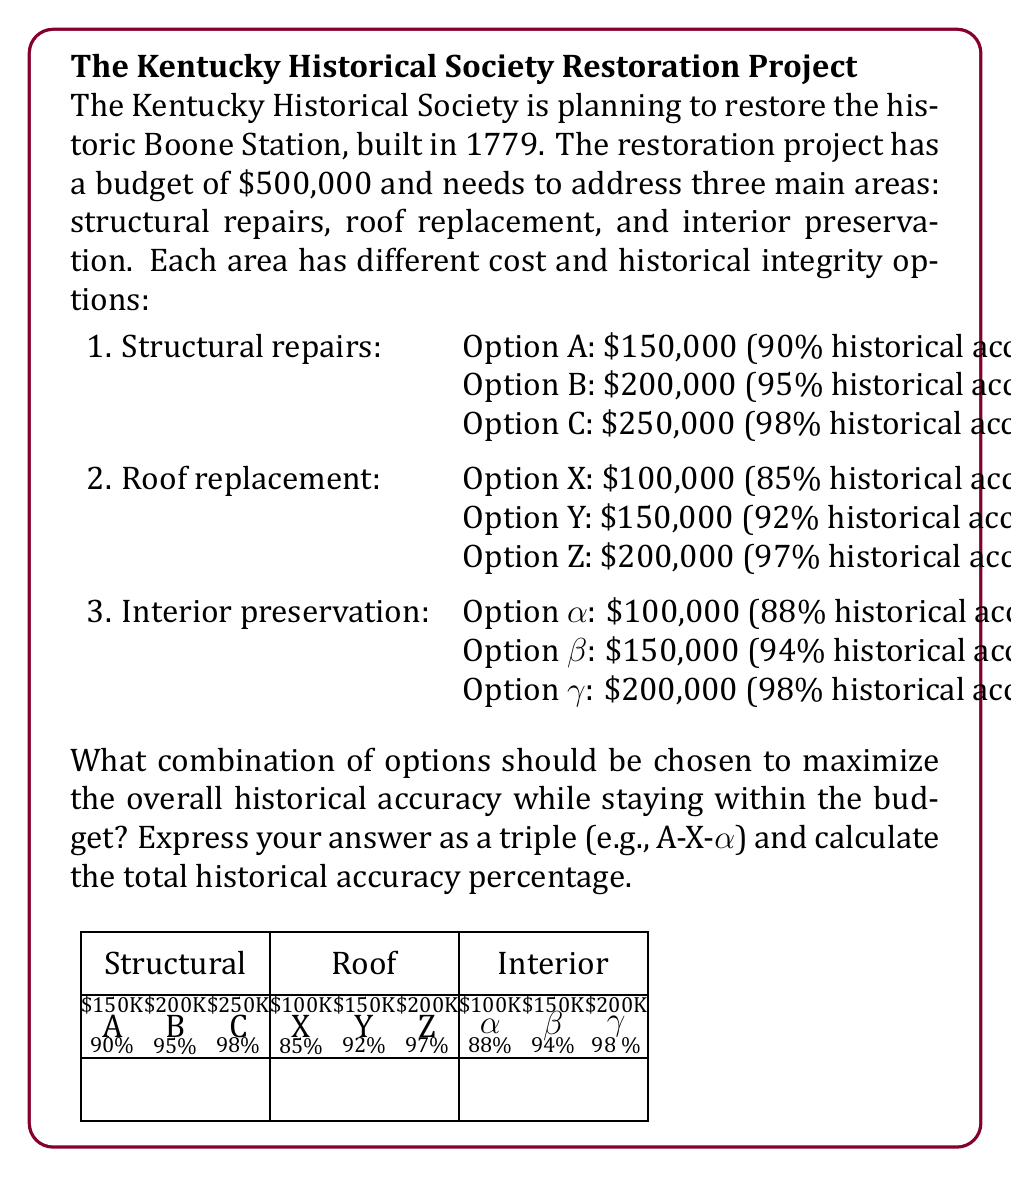What is the answer to this math problem? To solve this optimization problem, we need to find the combination that maximizes historical accuracy while staying within the $500,000 budget. Let's approach this step-by-step:

1) First, we need to list all possible combinations within the budget:
   B-X-α: $200,000 + $100,000 + $100,000 = $400,000
   B-X-β: $200,000 + $100,000 + $150,000 = $450,000
   B-Y-α: $200,000 + $150,000 + $100,000 = $450,000
   A-Y-β: $150,000 + $150,000 + $150,000 = $450,000
   A-Z-α: $150,000 + $200,000 + $100,000 = $450,000
   A-Y-γ: $150,000 + $150,000 + $200,000 = $500,000

2) Now, we calculate the overall historical accuracy for each combination. We'll use the average of the three percentages:

   B-X-α: $(95\% + 85\% + 88\%) / 3 = 89.33\%$
   B-X-β: $(95\% + 85\% + 94\%) / 3 = 91.33\%$
   B-Y-α: $(95\% + 92\% + 88\%) / 3 = 91.67\%$
   A-Y-β: $(90\% + 92\% + 94\%) / 3 = 92.00\%$
   A-Z-α: $(90\% + 97\% + 88\%) / 3 = 91.67\%$
   A-Y-γ: $(90\% + 92\% + 98\%) / 3 = 93.33\%$

3) The combination with the highest overall historical accuracy is A-Y-γ, with 93.33%.

Therefore, the optimal choice is to select Option A for structural repairs, Option Y for roof replacement, and Option γ for interior preservation.
Answer: A-Y-γ, 93.33% 